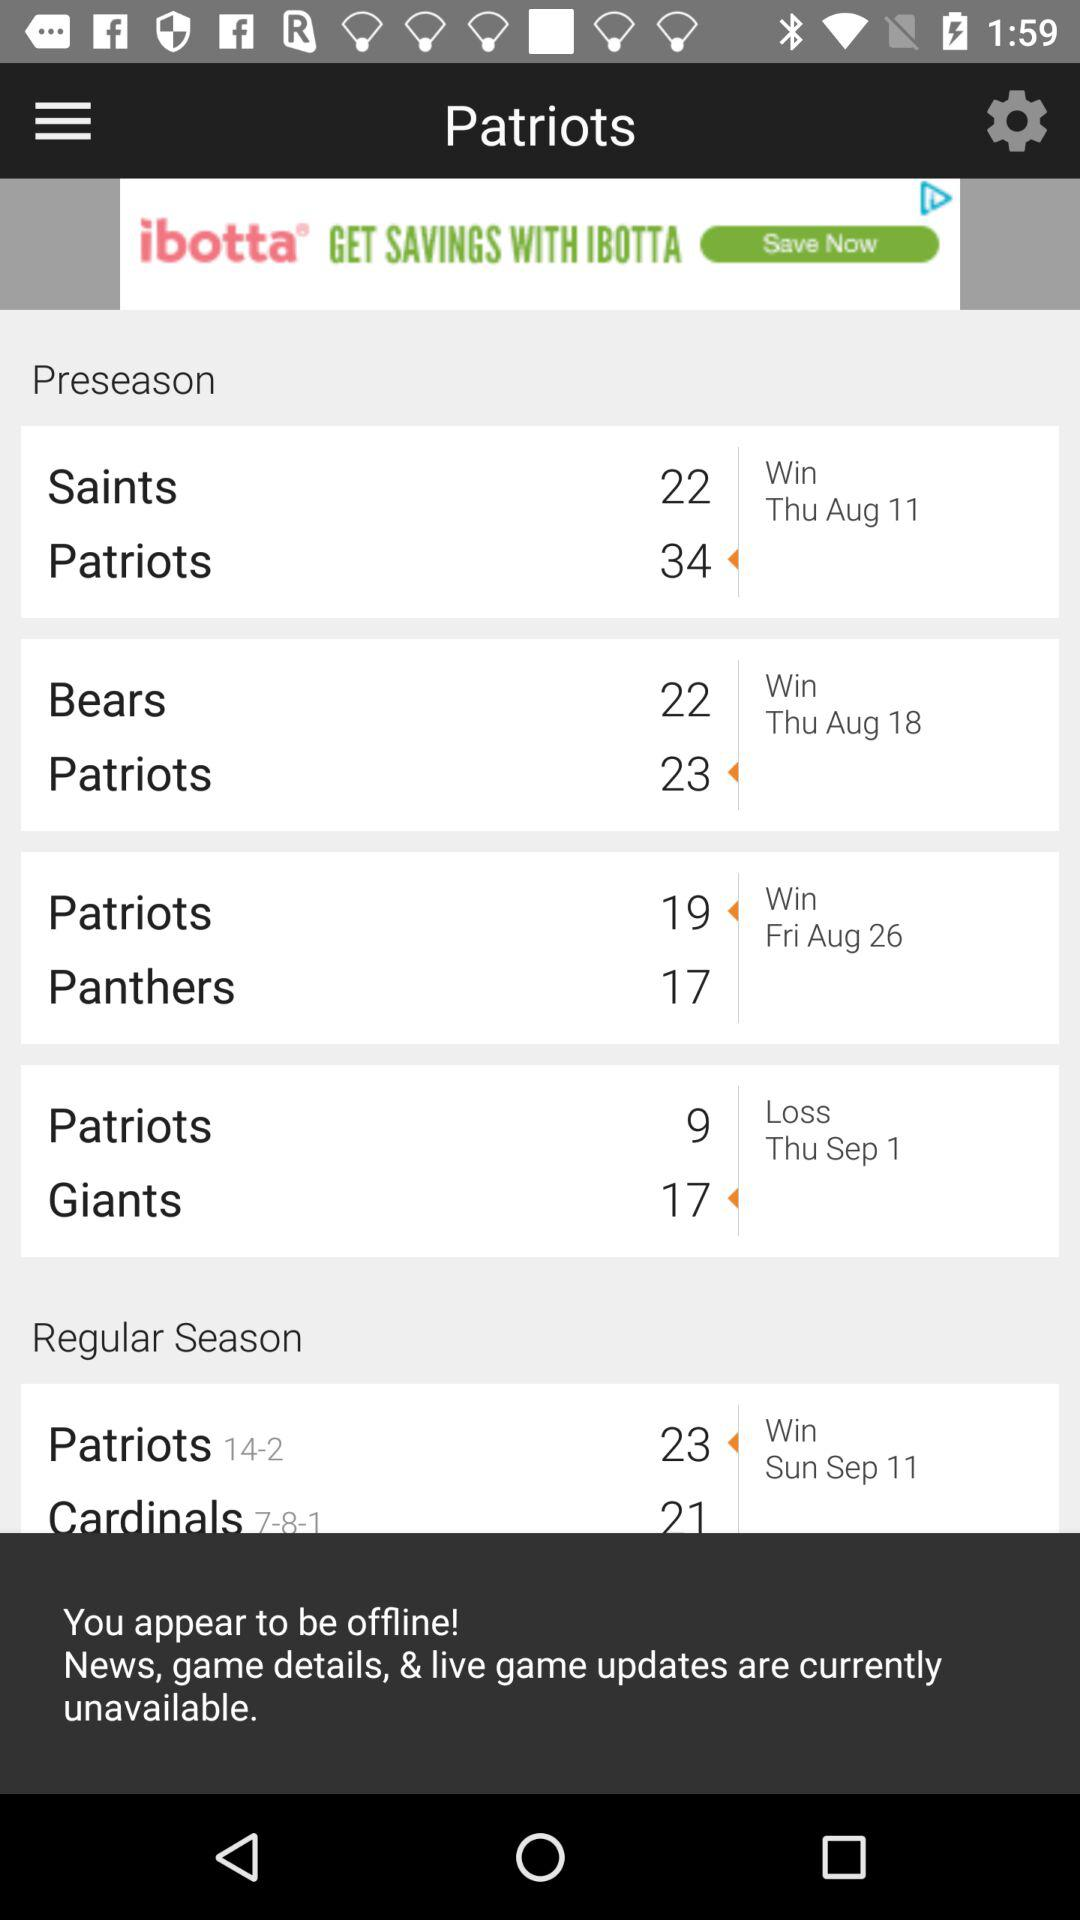What is the score of patriots on September 1? The score of patriots on September 1 is 9. 